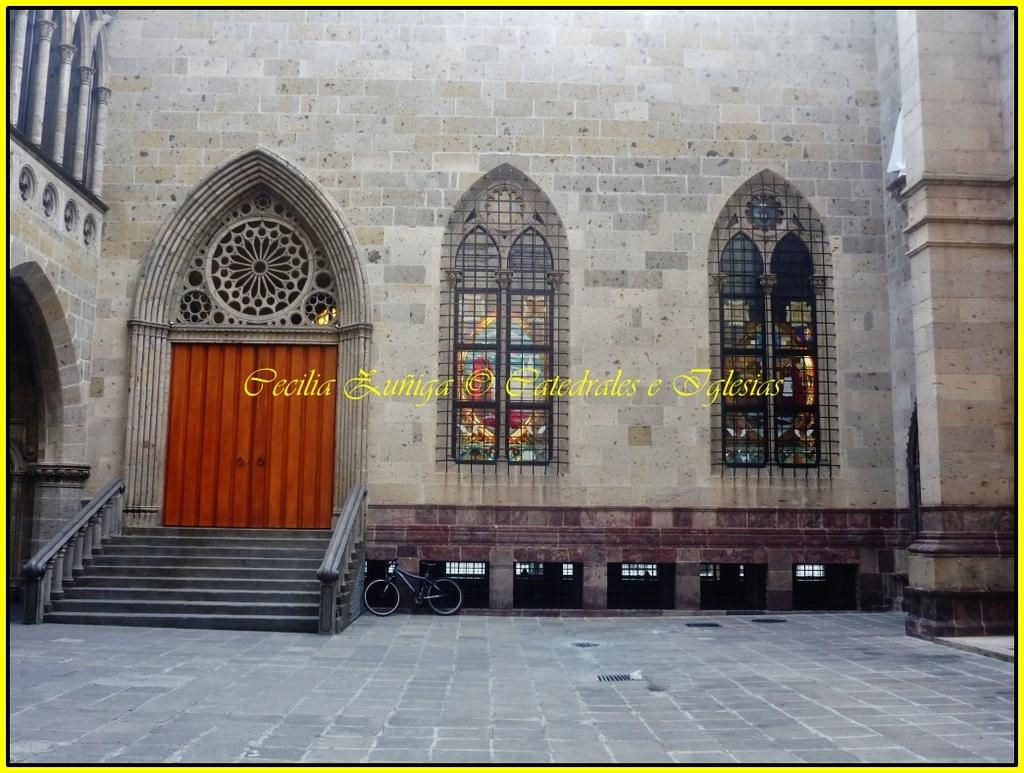What is present on the wall in the image? There is stained glass on the wall in the image. What is located in front of the wall? There is a bicycle in front of the wall. Can you describe the text in the middle of the image? There is some text in the middle of the image, but its content is not specified. What type of protest is taking place in the image? There is no protest present in the image; it features a wall with stained glass, a bicycle, and some text. How does the self-awareness of the bicycle change throughout the image? There is no indication of self-awareness or change in the image, as it is an inanimate object. 